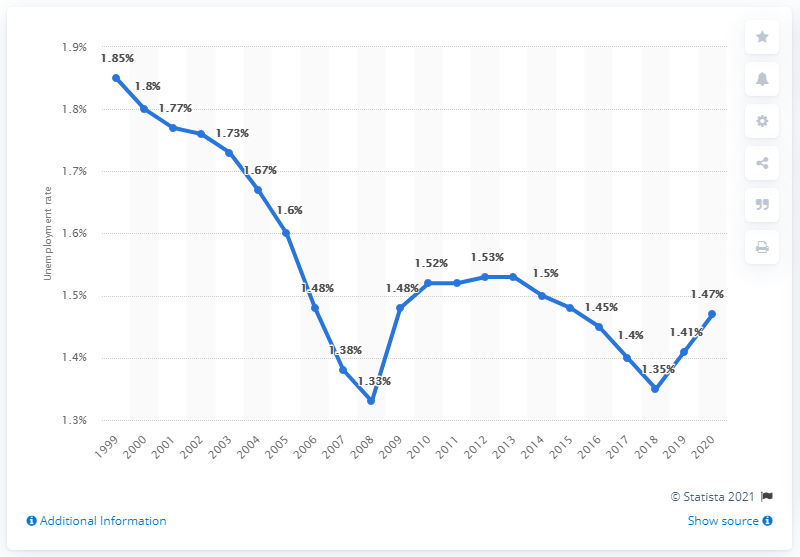Point out several critical features in this image. According to data from 2020, the unemployment rate in Nepal was 1.47%. 